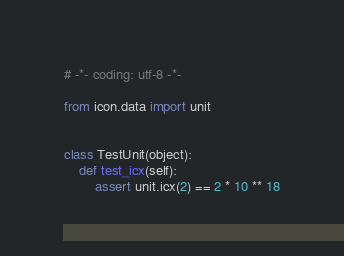<code> <loc_0><loc_0><loc_500><loc_500><_Python_># -*- coding: utf-8 -*-

from icon.data import unit


class TestUnit(object):
    def test_icx(self):
        assert unit.icx(2) == 2 * 10 ** 18
</code> 